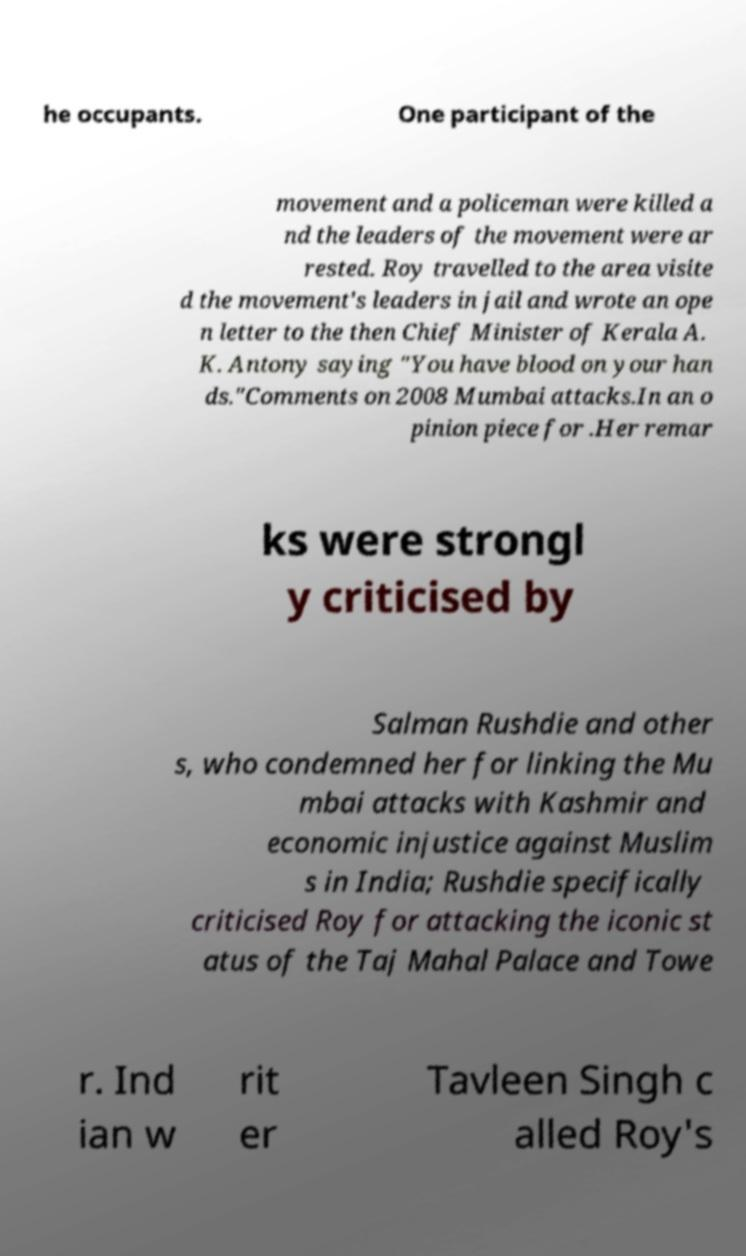I need the written content from this picture converted into text. Can you do that? he occupants. One participant of the movement and a policeman were killed a nd the leaders of the movement were ar rested. Roy travelled to the area visite d the movement's leaders in jail and wrote an ope n letter to the then Chief Minister of Kerala A. K. Antony saying "You have blood on your han ds."Comments on 2008 Mumbai attacks.In an o pinion piece for .Her remar ks were strongl y criticised by Salman Rushdie and other s, who condemned her for linking the Mu mbai attacks with Kashmir and economic injustice against Muslim s in India; Rushdie specifically criticised Roy for attacking the iconic st atus of the Taj Mahal Palace and Towe r. Ind ian w rit er Tavleen Singh c alled Roy's 